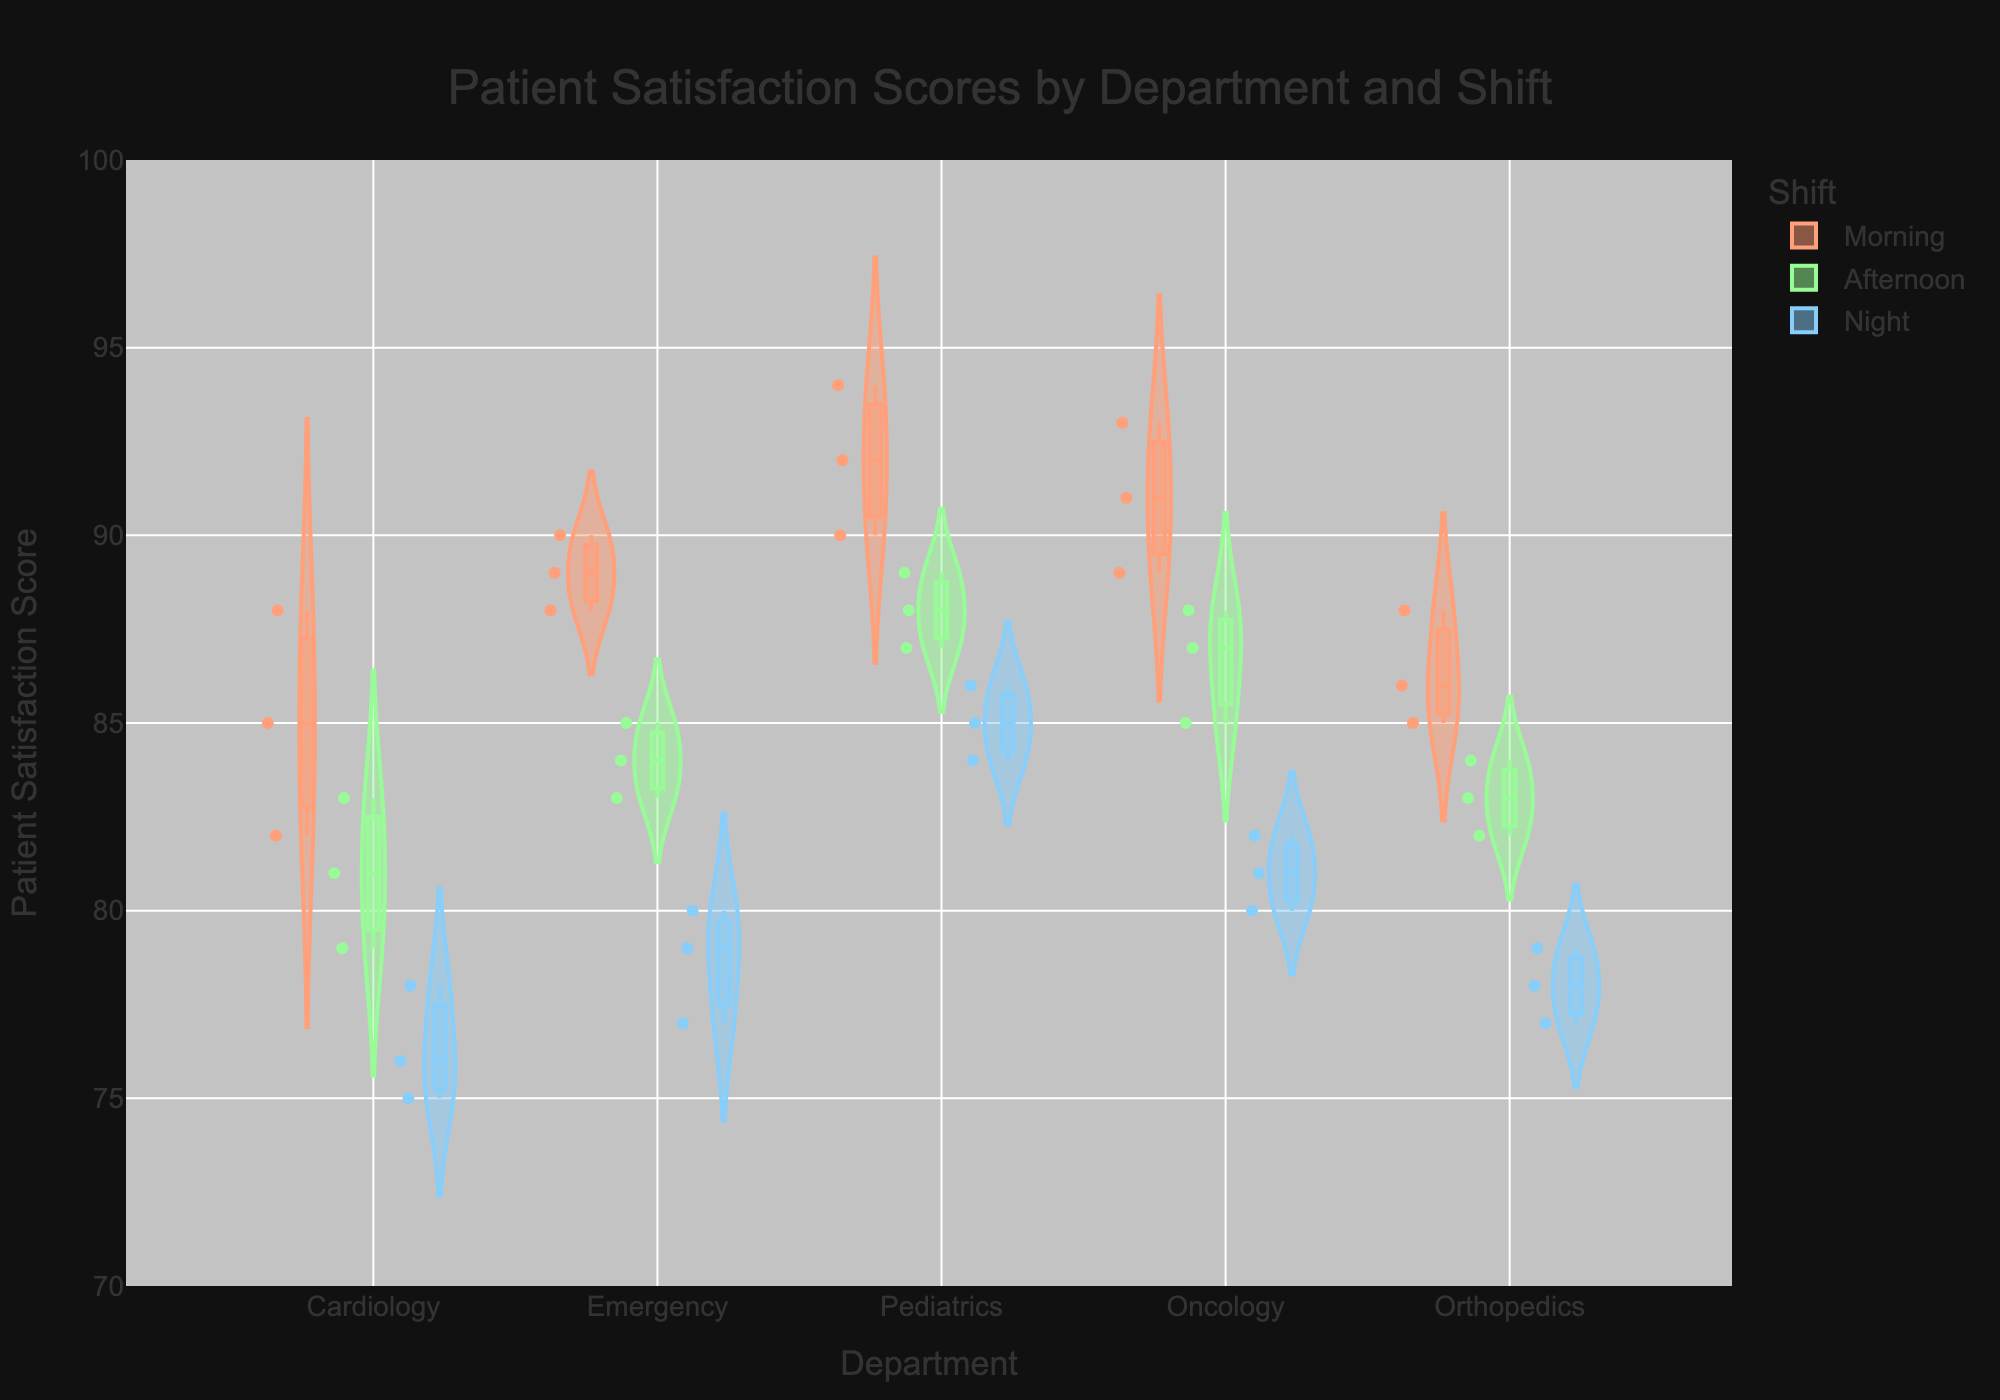What is the title of the violin chart? The title is always mentioned at the top section of a visual representation to give an idea about what the figure illustrates. In this chart, it says why it was created and what data it is showing.
Answer: Patient Satisfaction Scores by Department and Shift Which department has the highest median patient satisfaction score in the morning shift? The median is represented by the line inside the box plot within each violin plot. To find the highest one for the morning shift, look for the department where the median line of the orange-colored (morning shift) section is the highest.
Answer: Pediatrics In the Cardiology department, what is the range of patient satisfaction scores during the night shift? Inspect the blue violin plot for the night shift within the Cardiology department. The range is the difference between the highest and lowest points of this section.
Answer: 75 to 78 How does the distribution of patient satisfaction scores in the Orthopedics department during the afternoon shift compare to the morning shift? Compare the green-colored (afternoon shift) and orange-colored (morning shift) sections for Orthopedics. Pay attention to the spread, box plot, and density of the violin plots.
Answer: Afternoon shift scores are clustered around 82-84 and have a narrower spread compared to the morning shift which is around 85-88 Which department has the smallest interquartile range (IQR) for the night shift? The IQR is the range between the first quartile (Q1) and the third quartile (Q3) values, found inside the box plot within the violin plot for each department in the blue-colored section. Identify the box that is more compact.
Answer: Emergency What is the average patient satisfaction score for the Emergency department across all shifts? Calculate the average by summing up all the scores for the Emergency department and then dividing by the number of scores.
Answer: (89+90+88+85+83+84+79+77+80)/9 = 84.11 Which department shows the most consistent patient satisfaction scores across all shifts? Consistency can be inferred from how narrow and/tightly clustered the violin plots are within a department across all shifts. Look for the department with the least variability.
Answer: Orthopedics Are there more departments that have higher patient satisfaction scores in the morning shift compared to the night shift? Consider the medians or the overall position of the violin plots for each department in the morning (orange) and night (blue) shifts to determine if more departments have higher scores in the morning.
Answer: Yes Which department shows the widest variability in patient satisfaction scores in the afternoon shift? The department with the violin plot that spans the widest range of values in the green-colored section indicates the widest variability.
Answer: Cardiology 